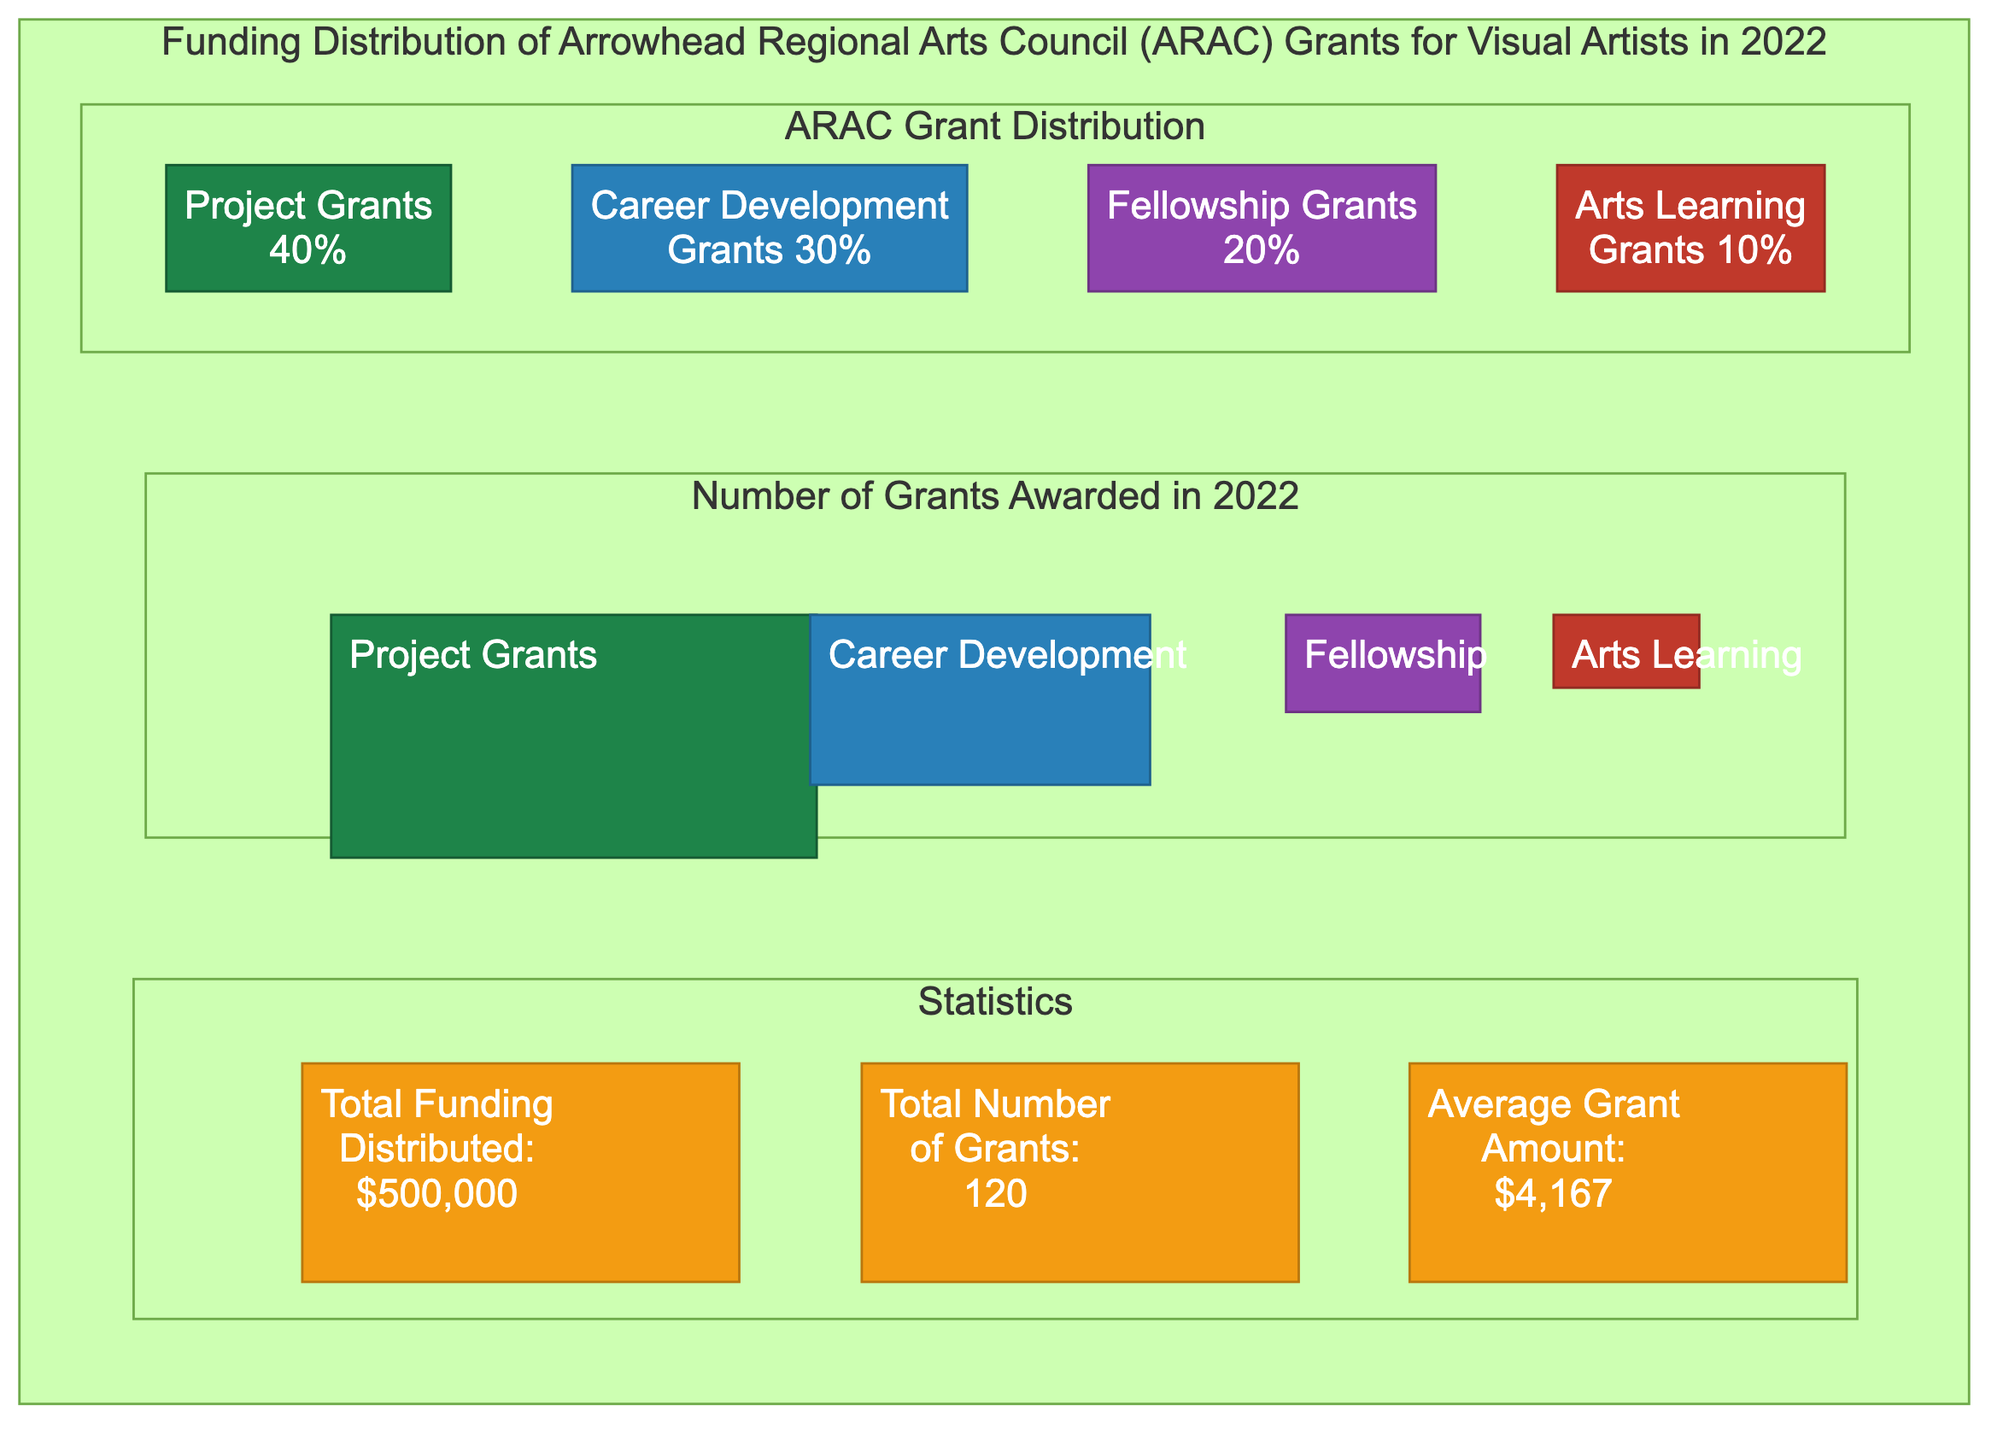What percentage of the total funding is allocated to Project Grants? The diagram states that Project Grants represent 40% of the total funding distribution. This can be found directly in the pie chart section of the diagram.
Answer: 40% How many total grants were awarded in 2022? The 'Statistics' section of the diagram indicates that a total of 120 grants were awarded in 2022. This figure is explicitly mentioned in the text.
Answer: 120 What is the average grant amount distributed? According to the 'Statistics' section, the average grant amount is $4,167, which is a specific figure shown in the diagram.
Answer: $4,167 Which grant category has the highest percentage of funding? The diagram shows that Project Grants have the highest percentage of funding at 40% as indicated in the pie chart section.
Answer: Project Grants How many Career Development Grants were awarded in 2022? In the 'Number of Grants Awarded in 2022', the bar labeled Career Development shows that 35 grants were awarded, making it a direct visual reference.
Answer: 35 What type of grant has the lowest percentage of funding? The pie chart indicates that Arts Learning Grants have the lowest funding percentage at 10%. This can be clearly identified in the diagram’s funding distribution visual.
Answer: Arts Learning Grants What is the total funding distributed across all grant types? The total funding distributed is stated in the 'Statistics' section as $500,000, which is a key summary figure in the diagram.
Answer: $500,000 What percentage of the total grants does Fellowship Grants represent? The diagram shows that Fellowship Grants account for 20% of the total funding distribution, clearly indicated in the pie chart section.
Answer: 20% 